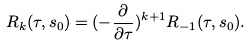Convert formula to latex. <formula><loc_0><loc_0><loc_500><loc_500>R _ { k } ( \tau , s _ { 0 } ) = ( - \frac { \partial } { \partial \tau } ) ^ { k + 1 } R _ { - 1 } ( \tau , s _ { 0 } ) .</formula> 